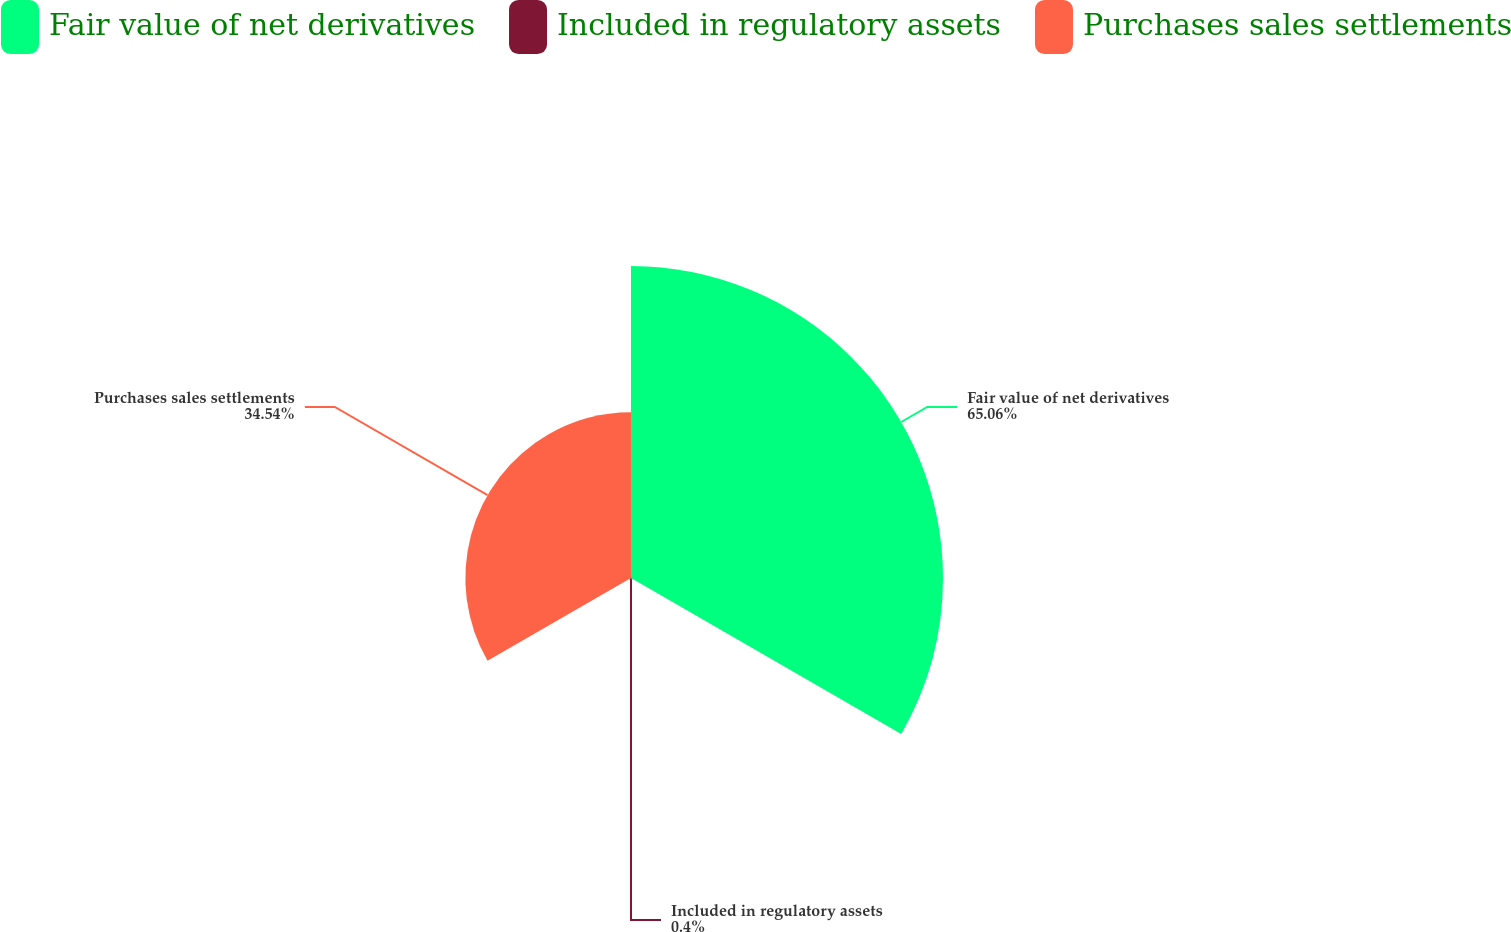<chart> <loc_0><loc_0><loc_500><loc_500><pie_chart><fcel>Fair value of net derivatives<fcel>Included in regulatory assets<fcel>Purchases sales settlements<nl><fcel>65.06%<fcel>0.4%<fcel>34.54%<nl></chart> 